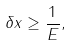<formula> <loc_0><loc_0><loc_500><loc_500>\delta x \geq \frac { 1 } { E } ,</formula> 